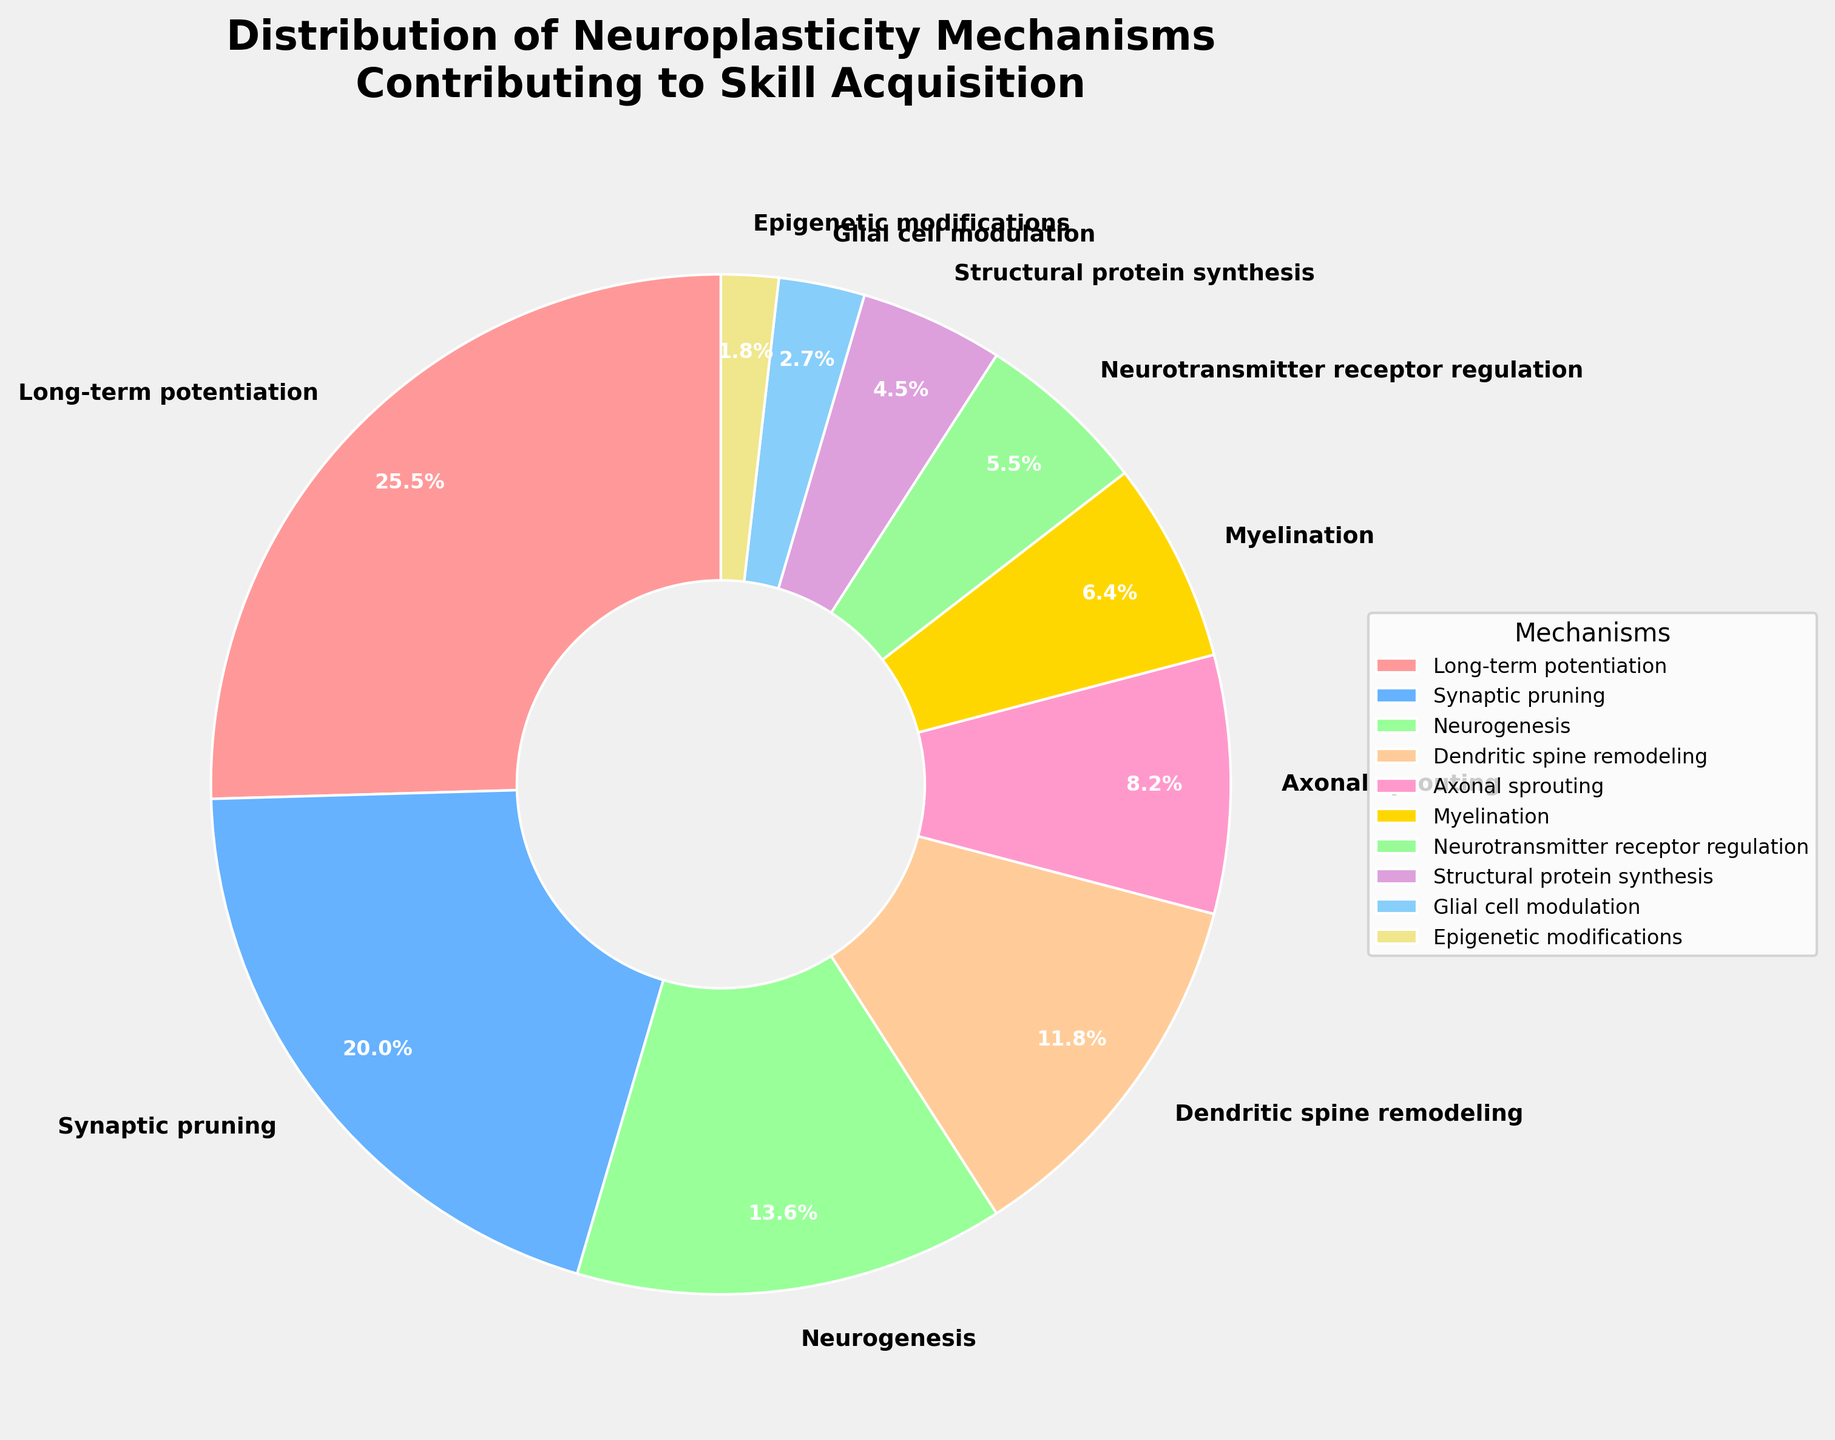What is the most prominent neuroplasticity mechanism contributing to skill acquisition? The pie chart shows the different mechanisms contributing to skill acquisition, with their corresponding percentages. The largest section represents Long-term potentiation, which has the highest percentage.
Answer: Long-term potentiation How much more in percentage does Long-term potentiation contribute compared to Synaptic pruning? Long-term potentiation contributes 28% and Synaptic pruning contributes 22%. The difference between them is 28 - 22 = 6%.
Answer: 6% Which mechanisms together make up exactly half of the total contributions? The total percentage for all mechanisms is 100%. To find which mechanisms sum up to 50%, we start from the largest: Long-term potentiation (28%) + Synaptic pruning (22%) = 50%.
Answer: Long-term potentiation and Synaptic pruning How does the contribution of Myelination compare to that of Dendritic spine remodeling? The pie chart indicates that Myelination contributes 7% and Dendritic spine remodeling contributes 13%. Therefore, Dendritic spine remodeling has a higher contribution than Myelination.
Answer: Dendritic spine remodeling has a higher contribution What portions of the pie chart have the same color, and what is their combined percentage? All portions of the pie chart have unique colors; no two slices share the same color.
Answer: No portions have the same color; 0% What percentage of the contributions come from Neurogenesis and Epigenetic modifications combined? Neurogenesis contributes 15% and Epigenetic modifications contribute 2%. The combined percentage is 15 + 2 = 17%.
Answer: 17% Which mechanism has the lowest contribution and what is its percentage? The pie chart shows the percentages for all mechanisms, and the lowest contribution is from Epigenetic modifications, with a value of 2%.
Answer: Epigenetic modifications, 2% What is the difference between Axonal sprouting and Neurotransmitter receptor regulation contributions? Axonal sprouting contributes 9% and Neurotransmitter receptor regulation contributes 6%. The difference is 9 - 6 = 3%.
Answer: 3% Is the contribution of Structural protein synthesis greater than that of Glial cell modulation? If so, by how much? Structural protein synthesis contributes 5% and Glial cell modulation contributes 3%. The difference is 5 - 3 = 2%. Yes, Structural protein synthesis contributes 2% more.
Answer: 2% How many mechanisms contribute more than 10% each to skill acquisition? The pie chart displays the percentages for each mechanism. By inspecting these, we find three mechanisms contributing more than 10%: Long-term potentiation (28%), Synaptic pruning (22%), and Neurogenesis (15%).
Answer: 3 